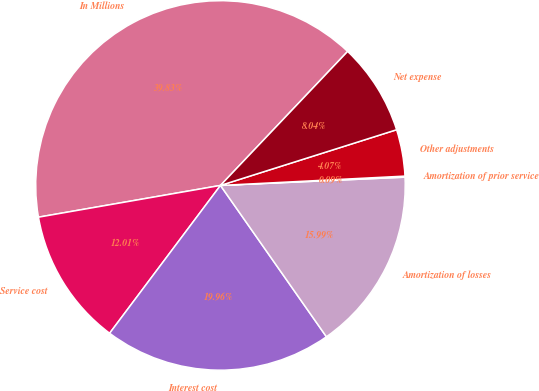Convert chart. <chart><loc_0><loc_0><loc_500><loc_500><pie_chart><fcel>In Millions<fcel>Service cost<fcel>Interest cost<fcel>Amortization of losses<fcel>Amortization of prior service<fcel>Other adjustments<fcel>Net expense<nl><fcel>39.83%<fcel>12.01%<fcel>19.96%<fcel>15.99%<fcel>0.09%<fcel>4.07%<fcel>8.04%<nl></chart> 